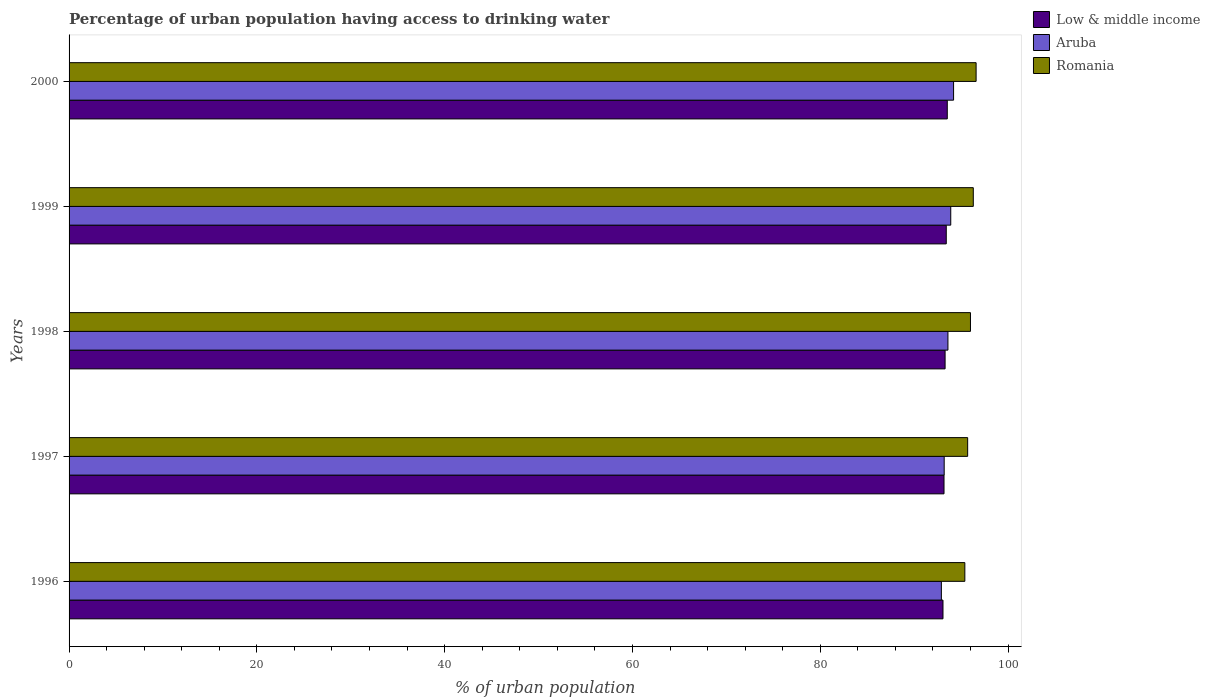How many different coloured bars are there?
Offer a terse response. 3. Are the number of bars per tick equal to the number of legend labels?
Offer a very short reply. Yes. Are the number of bars on each tick of the Y-axis equal?
Your answer should be very brief. Yes. How many bars are there on the 1st tick from the top?
Your answer should be compact. 3. What is the label of the 4th group of bars from the top?
Offer a very short reply. 1997. In how many cases, is the number of bars for a given year not equal to the number of legend labels?
Your answer should be compact. 0. What is the percentage of urban population having access to drinking water in Low & middle income in 1996?
Your answer should be compact. 93.07. Across all years, what is the maximum percentage of urban population having access to drinking water in Aruba?
Your answer should be compact. 94.2. Across all years, what is the minimum percentage of urban population having access to drinking water in Romania?
Your answer should be very brief. 95.4. In which year was the percentage of urban population having access to drinking water in Low & middle income maximum?
Give a very brief answer. 2000. What is the total percentage of urban population having access to drinking water in Low & middle income in the graph?
Ensure brevity in your answer.  466.5. What is the difference between the percentage of urban population having access to drinking water in Romania in 1996 and that in 2000?
Give a very brief answer. -1.2. What is the difference between the percentage of urban population having access to drinking water in Romania in 1997 and the percentage of urban population having access to drinking water in Aruba in 1999?
Your response must be concise. 1.8. What is the average percentage of urban population having access to drinking water in Aruba per year?
Keep it short and to the point. 93.56. In the year 2000, what is the difference between the percentage of urban population having access to drinking water in Romania and percentage of urban population having access to drinking water in Aruba?
Give a very brief answer. 2.4. In how many years, is the percentage of urban population having access to drinking water in Low & middle income greater than 40 %?
Make the answer very short. 5. What is the ratio of the percentage of urban population having access to drinking water in Romania in 1996 to that in 1997?
Offer a very short reply. 1. Is the difference between the percentage of urban population having access to drinking water in Romania in 1997 and 1999 greater than the difference between the percentage of urban population having access to drinking water in Aruba in 1997 and 1999?
Provide a short and direct response. Yes. What is the difference between the highest and the second highest percentage of urban population having access to drinking water in Romania?
Make the answer very short. 0.3. What is the difference between the highest and the lowest percentage of urban population having access to drinking water in Low & middle income?
Offer a very short reply. 0.46. What does the 2nd bar from the top in 1996 represents?
Provide a succinct answer. Aruba. What does the 2nd bar from the bottom in 1998 represents?
Your answer should be compact. Aruba. How many bars are there?
Keep it short and to the point. 15. Are all the bars in the graph horizontal?
Give a very brief answer. Yes. How many years are there in the graph?
Offer a terse response. 5. Does the graph contain any zero values?
Ensure brevity in your answer.  No. Does the graph contain grids?
Ensure brevity in your answer.  No. Where does the legend appear in the graph?
Keep it short and to the point. Top right. How are the legend labels stacked?
Provide a short and direct response. Vertical. What is the title of the graph?
Provide a succinct answer. Percentage of urban population having access to drinking water. Does "Lebanon" appear as one of the legend labels in the graph?
Give a very brief answer. No. What is the label or title of the X-axis?
Your answer should be compact. % of urban population. What is the % of urban population in Low & middle income in 1996?
Ensure brevity in your answer.  93.07. What is the % of urban population of Aruba in 1996?
Your answer should be very brief. 92.9. What is the % of urban population of Romania in 1996?
Offer a terse response. 95.4. What is the % of urban population of Low & middle income in 1997?
Provide a short and direct response. 93.18. What is the % of urban population of Aruba in 1997?
Keep it short and to the point. 93.2. What is the % of urban population of Romania in 1997?
Make the answer very short. 95.7. What is the % of urban population in Low & middle income in 1998?
Make the answer very short. 93.3. What is the % of urban population in Aruba in 1998?
Offer a very short reply. 93.6. What is the % of urban population of Romania in 1998?
Provide a succinct answer. 96. What is the % of urban population in Low & middle income in 1999?
Provide a short and direct response. 93.42. What is the % of urban population in Aruba in 1999?
Provide a succinct answer. 93.9. What is the % of urban population of Romania in 1999?
Your answer should be compact. 96.3. What is the % of urban population in Low & middle income in 2000?
Your answer should be compact. 93.53. What is the % of urban population in Aruba in 2000?
Provide a short and direct response. 94.2. What is the % of urban population of Romania in 2000?
Provide a short and direct response. 96.6. Across all years, what is the maximum % of urban population in Low & middle income?
Keep it short and to the point. 93.53. Across all years, what is the maximum % of urban population in Aruba?
Offer a very short reply. 94.2. Across all years, what is the maximum % of urban population of Romania?
Offer a very short reply. 96.6. Across all years, what is the minimum % of urban population in Low & middle income?
Your answer should be very brief. 93.07. Across all years, what is the minimum % of urban population in Aruba?
Offer a very short reply. 92.9. Across all years, what is the minimum % of urban population of Romania?
Give a very brief answer. 95.4. What is the total % of urban population in Low & middle income in the graph?
Offer a very short reply. 466.5. What is the total % of urban population in Aruba in the graph?
Provide a short and direct response. 467.8. What is the total % of urban population of Romania in the graph?
Give a very brief answer. 480. What is the difference between the % of urban population of Low & middle income in 1996 and that in 1997?
Your answer should be compact. -0.11. What is the difference between the % of urban population in Aruba in 1996 and that in 1997?
Provide a short and direct response. -0.3. What is the difference between the % of urban population in Romania in 1996 and that in 1997?
Ensure brevity in your answer.  -0.3. What is the difference between the % of urban population of Low & middle income in 1996 and that in 1998?
Make the answer very short. -0.22. What is the difference between the % of urban population in Aruba in 1996 and that in 1998?
Ensure brevity in your answer.  -0.7. What is the difference between the % of urban population in Romania in 1996 and that in 1998?
Give a very brief answer. -0.6. What is the difference between the % of urban population of Low & middle income in 1996 and that in 1999?
Provide a short and direct response. -0.35. What is the difference between the % of urban population in Aruba in 1996 and that in 1999?
Keep it short and to the point. -1. What is the difference between the % of urban population of Romania in 1996 and that in 1999?
Provide a succinct answer. -0.9. What is the difference between the % of urban population in Low & middle income in 1996 and that in 2000?
Keep it short and to the point. -0.46. What is the difference between the % of urban population in Low & middle income in 1997 and that in 1998?
Offer a very short reply. -0.11. What is the difference between the % of urban population in Aruba in 1997 and that in 1998?
Ensure brevity in your answer.  -0.4. What is the difference between the % of urban population in Low & middle income in 1997 and that in 1999?
Your response must be concise. -0.24. What is the difference between the % of urban population of Aruba in 1997 and that in 1999?
Provide a succinct answer. -0.7. What is the difference between the % of urban population in Low & middle income in 1997 and that in 2000?
Provide a succinct answer. -0.35. What is the difference between the % of urban population in Low & middle income in 1998 and that in 1999?
Your answer should be very brief. -0.12. What is the difference between the % of urban population of Romania in 1998 and that in 1999?
Offer a terse response. -0.3. What is the difference between the % of urban population of Low & middle income in 1998 and that in 2000?
Keep it short and to the point. -0.23. What is the difference between the % of urban population in Aruba in 1998 and that in 2000?
Keep it short and to the point. -0.6. What is the difference between the % of urban population of Romania in 1998 and that in 2000?
Give a very brief answer. -0.6. What is the difference between the % of urban population in Low & middle income in 1999 and that in 2000?
Make the answer very short. -0.11. What is the difference between the % of urban population in Aruba in 1999 and that in 2000?
Give a very brief answer. -0.3. What is the difference between the % of urban population in Romania in 1999 and that in 2000?
Provide a short and direct response. -0.3. What is the difference between the % of urban population of Low & middle income in 1996 and the % of urban population of Aruba in 1997?
Provide a succinct answer. -0.13. What is the difference between the % of urban population of Low & middle income in 1996 and the % of urban population of Romania in 1997?
Ensure brevity in your answer.  -2.63. What is the difference between the % of urban population in Low & middle income in 1996 and the % of urban population in Aruba in 1998?
Your answer should be very brief. -0.53. What is the difference between the % of urban population in Low & middle income in 1996 and the % of urban population in Romania in 1998?
Provide a succinct answer. -2.93. What is the difference between the % of urban population of Low & middle income in 1996 and the % of urban population of Aruba in 1999?
Your response must be concise. -0.83. What is the difference between the % of urban population of Low & middle income in 1996 and the % of urban population of Romania in 1999?
Make the answer very short. -3.23. What is the difference between the % of urban population of Low & middle income in 1996 and the % of urban population of Aruba in 2000?
Give a very brief answer. -1.13. What is the difference between the % of urban population of Low & middle income in 1996 and the % of urban population of Romania in 2000?
Offer a terse response. -3.53. What is the difference between the % of urban population in Low & middle income in 1997 and the % of urban population in Aruba in 1998?
Your response must be concise. -0.42. What is the difference between the % of urban population in Low & middle income in 1997 and the % of urban population in Romania in 1998?
Provide a short and direct response. -2.82. What is the difference between the % of urban population of Aruba in 1997 and the % of urban population of Romania in 1998?
Your response must be concise. -2.8. What is the difference between the % of urban population of Low & middle income in 1997 and the % of urban population of Aruba in 1999?
Offer a very short reply. -0.72. What is the difference between the % of urban population of Low & middle income in 1997 and the % of urban population of Romania in 1999?
Your response must be concise. -3.12. What is the difference between the % of urban population in Aruba in 1997 and the % of urban population in Romania in 1999?
Your answer should be compact. -3.1. What is the difference between the % of urban population in Low & middle income in 1997 and the % of urban population in Aruba in 2000?
Provide a short and direct response. -1.02. What is the difference between the % of urban population in Low & middle income in 1997 and the % of urban population in Romania in 2000?
Provide a short and direct response. -3.42. What is the difference between the % of urban population in Low & middle income in 1998 and the % of urban population in Aruba in 1999?
Make the answer very short. -0.6. What is the difference between the % of urban population of Low & middle income in 1998 and the % of urban population of Romania in 1999?
Offer a terse response. -3. What is the difference between the % of urban population in Low & middle income in 1998 and the % of urban population in Aruba in 2000?
Give a very brief answer. -0.9. What is the difference between the % of urban population of Low & middle income in 1998 and the % of urban population of Romania in 2000?
Provide a succinct answer. -3.3. What is the difference between the % of urban population of Low & middle income in 1999 and the % of urban population of Aruba in 2000?
Provide a succinct answer. -0.78. What is the difference between the % of urban population in Low & middle income in 1999 and the % of urban population in Romania in 2000?
Provide a succinct answer. -3.18. What is the average % of urban population in Low & middle income per year?
Make the answer very short. 93.3. What is the average % of urban population in Aruba per year?
Your answer should be compact. 93.56. What is the average % of urban population in Romania per year?
Give a very brief answer. 96. In the year 1996, what is the difference between the % of urban population in Low & middle income and % of urban population in Aruba?
Provide a short and direct response. 0.17. In the year 1996, what is the difference between the % of urban population of Low & middle income and % of urban population of Romania?
Your answer should be very brief. -2.33. In the year 1996, what is the difference between the % of urban population in Aruba and % of urban population in Romania?
Provide a succinct answer. -2.5. In the year 1997, what is the difference between the % of urban population of Low & middle income and % of urban population of Aruba?
Your answer should be very brief. -0.02. In the year 1997, what is the difference between the % of urban population in Low & middle income and % of urban population in Romania?
Make the answer very short. -2.52. In the year 1997, what is the difference between the % of urban population of Aruba and % of urban population of Romania?
Keep it short and to the point. -2.5. In the year 1998, what is the difference between the % of urban population of Low & middle income and % of urban population of Aruba?
Offer a terse response. -0.3. In the year 1998, what is the difference between the % of urban population in Low & middle income and % of urban population in Romania?
Give a very brief answer. -2.7. In the year 1998, what is the difference between the % of urban population of Aruba and % of urban population of Romania?
Make the answer very short. -2.4. In the year 1999, what is the difference between the % of urban population of Low & middle income and % of urban population of Aruba?
Your answer should be very brief. -0.48. In the year 1999, what is the difference between the % of urban population of Low & middle income and % of urban population of Romania?
Your answer should be very brief. -2.88. In the year 1999, what is the difference between the % of urban population of Aruba and % of urban population of Romania?
Provide a succinct answer. -2.4. In the year 2000, what is the difference between the % of urban population of Low & middle income and % of urban population of Aruba?
Give a very brief answer. -0.67. In the year 2000, what is the difference between the % of urban population of Low & middle income and % of urban population of Romania?
Ensure brevity in your answer.  -3.07. What is the ratio of the % of urban population of Aruba in 1996 to that in 1997?
Provide a succinct answer. 1. What is the ratio of the % of urban population in Aruba in 1996 to that in 1998?
Offer a very short reply. 0.99. What is the ratio of the % of urban population in Low & middle income in 1996 to that in 1999?
Your answer should be compact. 1. What is the ratio of the % of urban population in Aruba in 1996 to that in 1999?
Offer a terse response. 0.99. What is the ratio of the % of urban population of Romania in 1996 to that in 1999?
Offer a very short reply. 0.99. What is the ratio of the % of urban population in Aruba in 1996 to that in 2000?
Provide a succinct answer. 0.99. What is the ratio of the % of urban population of Romania in 1996 to that in 2000?
Your answer should be very brief. 0.99. What is the ratio of the % of urban population in Low & middle income in 1997 to that in 1998?
Keep it short and to the point. 1. What is the ratio of the % of urban population in Aruba in 1997 to that in 1998?
Provide a succinct answer. 1. What is the ratio of the % of urban population in Low & middle income in 1997 to that in 1999?
Your answer should be very brief. 1. What is the ratio of the % of urban population of Romania in 1997 to that in 1999?
Your response must be concise. 0.99. What is the ratio of the % of urban population of Low & middle income in 1997 to that in 2000?
Give a very brief answer. 1. What is the ratio of the % of urban population in Low & middle income in 1998 to that in 1999?
Provide a succinct answer. 1. What is the ratio of the % of urban population in Aruba in 1998 to that in 1999?
Offer a very short reply. 1. What is the ratio of the % of urban population of Romania in 1998 to that in 1999?
Your answer should be compact. 1. What is the difference between the highest and the second highest % of urban population of Low & middle income?
Give a very brief answer. 0.11. What is the difference between the highest and the second highest % of urban population of Romania?
Your answer should be compact. 0.3. What is the difference between the highest and the lowest % of urban population of Low & middle income?
Your answer should be compact. 0.46. What is the difference between the highest and the lowest % of urban population of Aruba?
Your response must be concise. 1.3. What is the difference between the highest and the lowest % of urban population of Romania?
Make the answer very short. 1.2. 